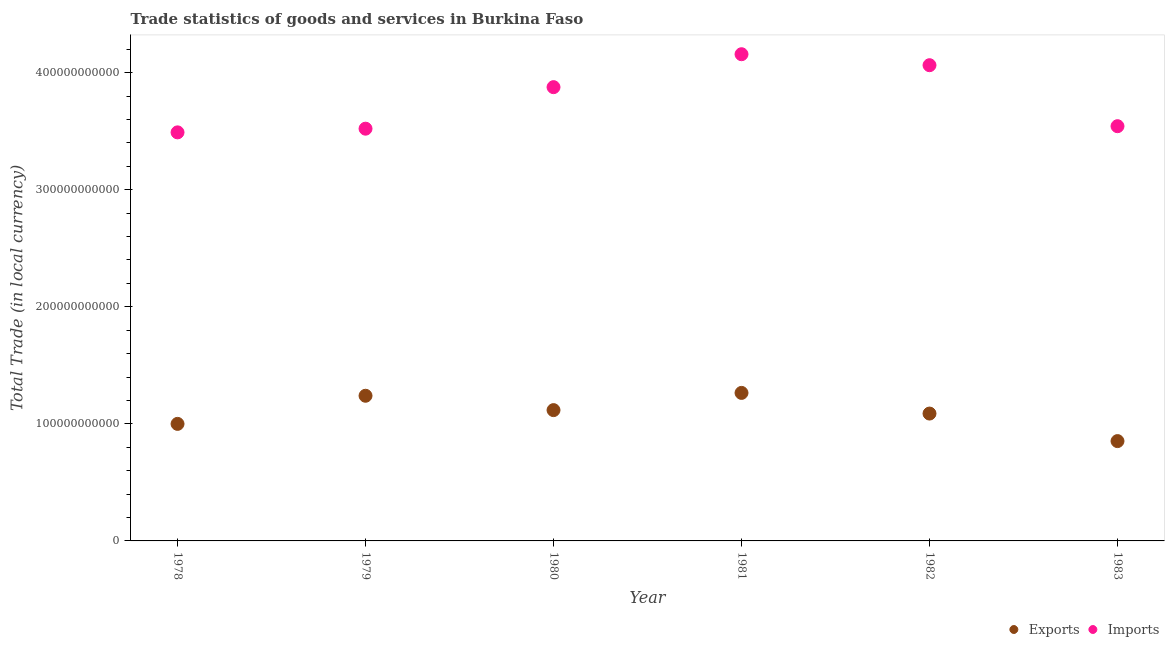How many different coloured dotlines are there?
Keep it short and to the point. 2. What is the imports of goods and services in 1981?
Give a very brief answer. 4.16e+11. Across all years, what is the maximum imports of goods and services?
Offer a very short reply. 4.16e+11. Across all years, what is the minimum export of goods and services?
Give a very brief answer. 8.53e+1. In which year was the export of goods and services minimum?
Offer a terse response. 1983. What is the total export of goods and services in the graph?
Keep it short and to the point. 6.56e+11. What is the difference between the export of goods and services in 1979 and that in 1980?
Offer a terse response. 1.23e+1. What is the difference between the imports of goods and services in 1979 and the export of goods and services in 1978?
Offer a very short reply. 2.52e+11. What is the average imports of goods and services per year?
Keep it short and to the point. 3.78e+11. In the year 1978, what is the difference between the imports of goods and services and export of goods and services?
Ensure brevity in your answer.  2.49e+11. What is the ratio of the imports of goods and services in 1981 to that in 1983?
Your response must be concise. 1.17. Is the difference between the export of goods and services in 1982 and 1983 greater than the difference between the imports of goods and services in 1982 and 1983?
Give a very brief answer. No. What is the difference between the highest and the second highest export of goods and services?
Make the answer very short. 2.44e+09. What is the difference between the highest and the lowest imports of goods and services?
Your answer should be very brief. 6.68e+1. In how many years, is the export of goods and services greater than the average export of goods and services taken over all years?
Your answer should be very brief. 3. Is the sum of the imports of goods and services in 1978 and 1979 greater than the maximum export of goods and services across all years?
Your answer should be very brief. Yes. Is the export of goods and services strictly greater than the imports of goods and services over the years?
Offer a very short reply. No. Is the export of goods and services strictly less than the imports of goods and services over the years?
Give a very brief answer. Yes. What is the difference between two consecutive major ticks on the Y-axis?
Provide a short and direct response. 1.00e+11. Does the graph contain any zero values?
Make the answer very short. No. How many legend labels are there?
Provide a short and direct response. 2. How are the legend labels stacked?
Offer a very short reply. Horizontal. What is the title of the graph?
Offer a very short reply. Trade statistics of goods and services in Burkina Faso. What is the label or title of the X-axis?
Provide a short and direct response. Year. What is the label or title of the Y-axis?
Keep it short and to the point. Total Trade (in local currency). What is the Total Trade (in local currency) of Exports in 1978?
Give a very brief answer. 1.00e+11. What is the Total Trade (in local currency) in Imports in 1978?
Your answer should be very brief. 3.49e+11. What is the Total Trade (in local currency) in Exports in 1979?
Keep it short and to the point. 1.24e+11. What is the Total Trade (in local currency) of Imports in 1979?
Provide a short and direct response. 3.52e+11. What is the Total Trade (in local currency) of Exports in 1980?
Make the answer very short. 1.12e+11. What is the Total Trade (in local currency) in Imports in 1980?
Your answer should be compact. 3.88e+11. What is the Total Trade (in local currency) in Exports in 1981?
Make the answer very short. 1.26e+11. What is the Total Trade (in local currency) of Imports in 1981?
Keep it short and to the point. 4.16e+11. What is the Total Trade (in local currency) in Exports in 1982?
Ensure brevity in your answer.  1.09e+11. What is the Total Trade (in local currency) of Imports in 1982?
Provide a short and direct response. 4.06e+11. What is the Total Trade (in local currency) of Exports in 1983?
Offer a terse response. 8.53e+1. What is the Total Trade (in local currency) in Imports in 1983?
Your response must be concise. 3.54e+11. Across all years, what is the maximum Total Trade (in local currency) of Exports?
Make the answer very short. 1.26e+11. Across all years, what is the maximum Total Trade (in local currency) of Imports?
Make the answer very short. 4.16e+11. Across all years, what is the minimum Total Trade (in local currency) of Exports?
Make the answer very short. 8.53e+1. Across all years, what is the minimum Total Trade (in local currency) of Imports?
Keep it short and to the point. 3.49e+11. What is the total Total Trade (in local currency) of Exports in the graph?
Keep it short and to the point. 6.56e+11. What is the total Total Trade (in local currency) of Imports in the graph?
Offer a very short reply. 2.27e+12. What is the difference between the Total Trade (in local currency) of Exports in 1978 and that in 1979?
Keep it short and to the point. -2.40e+1. What is the difference between the Total Trade (in local currency) of Imports in 1978 and that in 1979?
Provide a succinct answer. -3.14e+09. What is the difference between the Total Trade (in local currency) in Exports in 1978 and that in 1980?
Offer a very short reply. -1.18e+1. What is the difference between the Total Trade (in local currency) of Imports in 1978 and that in 1980?
Your answer should be compact. -3.86e+1. What is the difference between the Total Trade (in local currency) of Exports in 1978 and that in 1981?
Provide a short and direct response. -2.65e+1. What is the difference between the Total Trade (in local currency) in Imports in 1978 and that in 1981?
Your answer should be compact. -6.68e+1. What is the difference between the Total Trade (in local currency) in Exports in 1978 and that in 1982?
Your answer should be very brief. -8.82e+09. What is the difference between the Total Trade (in local currency) in Imports in 1978 and that in 1982?
Keep it short and to the point. -5.74e+1. What is the difference between the Total Trade (in local currency) of Exports in 1978 and that in 1983?
Offer a terse response. 1.47e+1. What is the difference between the Total Trade (in local currency) of Imports in 1978 and that in 1983?
Make the answer very short. -5.27e+09. What is the difference between the Total Trade (in local currency) of Exports in 1979 and that in 1980?
Your response must be concise. 1.23e+1. What is the difference between the Total Trade (in local currency) in Imports in 1979 and that in 1980?
Offer a very short reply. -3.55e+1. What is the difference between the Total Trade (in local currency) of Exports in 1979 and that in 1981?
Ensure brevity in your answer.  -2.44e+09. What is the difference between the Total Trade (in local currency) of Imports in 1979 and that in 1981?
Your answer should be very brief. -6.36e+1. What is the difference between the Total Trade (in local currency) in Exports in 1979 and that in 1982?
Make the answer very short. 1.52e+1. What is the difference between the Total Trade (in local currency) in Imports in 1979 and that in 1982?
Provide a short and direct response. -5.42e+1. What is the difference between the Total Trade (in local currency) in Exports in 1979 and that in 1983?
Offer a very short reply. 3.87e+1. What is the difference between the Total Trade (in local currency) in Imports in 1979 and that in 1983?
Provide a succinct answer. -2.13e+09. What is the difference between the Total Trade (in local currency) in Exports in 1980 and that in 1981?
Make the answer very short. -1.47e+1. What is the difference between the Total Trade (in local currency) of Imports in 1980 and that in 1981?
Keep it short and to the point. -2.81e+1. What is the difference between the Total Trade (in local currency) of Exports in 1980 and that in 1982?
Your answer should be very brief. 2.94e+09. What is the difference between the Total Trade (in local currency) of Imports in 1980 and that in 1982?
Provide a succinct answer. -1.88e+1. What is the difference between the Total Trade (in local currency) of Exports in 1980 and that in 1983?
Make the answer very short. 2.65e+1. What is the difference between the Total Trade (in local currency) in Imports in 1980 and that in 1983?
Your answer should be compact. 3.33e+1. What is the difference between the Total Trade (in local currency) of Exports in 1981 and that in 1982?
Your response must be concise. 1.76e+1. What is the difference between the Total Trade (in local currency) of Imports in 1981 and that in 1982?
Ensure brevity in your answer.  9.38e+09. What is the difference between the Total Trade (in local currency) of Exports in 1981 and that in 1983?
Give a very brief answer. 4.12e+1. What is the difference between the Total Trade (in local currency) of Imports in 1981 and that in 1983?
Give a very brief answer. 6.15e+1. What is the difference between the Total Trade (in local currency) in Exports in 1982 and that in 1983?
Keep it short and to the point. 2.35e+1. What is the difference between the Total Trade (in local currency) in Imports in 1982 and that in 1983?
Provide a succinct answer. 5.21e+1. What is the difference between the Total Trade (in local currency) in Exports in 1978 and the Total Trade (in local currency) in Imports in 1979?
Offer a very short reply. -2.52e+11. What is the difference between the Total Trade (in local currency) in Exports in 1978 and the Total Trade (in local currency) in Imports in 1980?
Your answer should be compact. -2.88e+11. What is the difference between the Total Trade (in local currency) of Exports in 1978 and the Total Trade (in local currency) of Imports in 1981?
Your response must be concise. -3.16e+11. What is the difference between the Total Trade (in local currency) of Exports in 1978 and the Total Trade (in local currency) of Imports in 1982?
Keep it short and to the point. -3.06e+11. What is the difference between the Total Trade (in local currency) in Exports in 1978 and the Total Trade (in local currency) in Imports in 1983?
Your response must be concise. -2.54e+11. What is the difference between the Total Trade (in local currency) of Exports in 1979 and the Total Trade (in local currency) of Imports in 1980?
Offer a terse response. -2.64e+11. What is the difference between the Total Trade (in local currency) in Exports in 1979 and the Total Trade (in local currency) in Imports in 1981?
Provide a succinct answer. -2.92e+11. What is the difference between the Total Trade (in local currency) in Exports in 1979 and the Total Trade (in local currency) in Imports in 1982?
Ensure brevity in your answer.  -2.82e+11. What is the difference between the Total Trade (in local currency) of Exports in 1979 and the Total Trade (in local currency) of Imports in 1983?
Provide a succinct answer. -2.30e+11. What is the difference between the Total Trade (in local currency) in Exports in 1980 and the Total Trade (in local currency) in Imports in 1981?
Your response must be concise. -3.04e+11. What is the difference between the Total Trade (in local currency) in Exports in 1980 and the Total Trade (in local currency) in Imports in 1982?
Offer a terse response. -2.95e+11. What is the difference between the Total Trade (in local currency) in Exports in 1980 and the Total Trade (in local currency) in Imports in 1983?
Offer a terse response. -2.43e+11. What is the difference between the Total Trade (in local currency) in Exports in 1981 and the Total Trade (in local currency) in Imports in 1982?
Provide a succinct answer. -2.80e+11. What is the difference between the Total Trade (in local currency) of Exports in 1981 and the Total Trade (in local currency) of Imports in 1983?
Make the answer very short. -2.28e+11. What is the difference between the Total Trade (in local currency) of Exports in 1982 and the Total Trade (in local currency) of Imports in 1983?
Give a very brief answer. -2.46e+11. What is the average Total Trade (in local currency) of Exports per year?
Make the answer very short. 1.09e+11. What is the average Total Trade (in local currency) in Imports per year?
Your answer should be compact. 3.78e+11. In the year 1978, what is the difference between the Total Trade (in local currency) of Exports and Total Trade (in local currency) of Imports?
Give a very brief answer. -2.49e+11. In the year 1979, what is the difference between the Total Trade (in local currency) in Exports and Total Trade (in local currency) in Imports?
Provide a succinct answer. -2.28e+11. In the year 1980, what is the difference between the Total Trade (in local currency) of Exports and Total Trade (in local currency) of Imports?
Provide a short and direct response. -2.76e+11. In the year 1981, what is the difference between the Total Trade (in local currency) of Exports and Total Trade (in local currency) of Imports?
Offer a very short reply. -2.89e+11. In the year 1982, what is the difference between the Total Trade (in local currency) of Exports and Total Trade (in local currency) of Imports?
Your answer should be compact. -2.98e+11. In the year 1983, what is the difference between the Total Trade (in local currency) in Exports and Total Trade (in local currency) in Imports?
Your answer should be very brief. -2.69e+11. What is the ratio of the Total Trade (in local currency) in Exports in 1978 to that in 1979?
Provide a succinct answer. 0.81. What is the ratio of the Total Trade (in local currency) in Imports in 1978 to that in 1979?
Keep it short and to the point. 0.99. What is the ratio of the Total Trade (in local currency) in Exports in 1978 to that in 1980?
Your answer should be compact. 0.89. What is the ratio of the Total Trade (in local currency) of Imports in 1978 to that in 1980?
Make the answer very short. 0.9. What is the ratio of the Total Trade (in local currency) of Exports in 1978 to that in 1981?
Make the answer very short. 0.79. What is the ratio of the Total Trade (in local currency) in Imports in 1978 to that in 1981?
Offer a very short reply. 0.84. What is the ratio of the Total Trade (in local currency) of Exports in 1978 to that in 1982?
Your answer should be very brief. 0.92. What is the ratio of the Total Trade (in local currency) of Imports in 1978 to that in 1982?
Give a very brief answer. 0.86. What is the ratio of the Total Trade (in local currency) of Exports in 1978 to that in 1983?
Make the answer very short. 1.17. What is the ratio of the Total Trade (in local currency) in Imports in 1978 to that in 1983?
Keep it short and to the point. 0.99. What is the ratio of the Total Trade (in local currency) in Exports in 1979 to that in 1980?
Provide a succinct answer. 1.11. What is the ratio of the Total Trade (in local currency) in Imports in 1979 to that in 1980?
Keep it short and to the point. 0.91. What is the ratio of the Total Trade (in local currency) in Exports in 1979 to that in 1981?
Your answer should be very brief. 0.98. What is the ratio of the Total Trade (in local currency) of Imports in 1979 to that in 1981?
Offer a very short reply. 0.85. What is the ratio of the Total Trade (in local currency) in Exports in 1979 to that in 1982?
Provide a short and direct response. 1.14. What is the ratio of the Total Trade (in local currency) of Imports in 1979 to that in 1982?
Offer a terse response. 0.87. What is the ratio of the Total Trade (in local currency) in Exports in 1979 to that in 1983?
Your answer should be compact. 1.45. What is the ratio of the Total Trade (in local currency) of Imports in 1979 to that in 1983?
Make the answer very short. 0.99. What is the ratio of the Total Trade (in local currency) of Exports in 1980 to that in 1981?
Offer a terse response. 0.88. What is the ratio of the Total Trade (in local currency) in Imports in 1980 to that in 1981?
Provide a short and direct response. 0.93. What is the ratio of the Total Trade (in local currency) in Exports in 1980 to that in 1982?
Ensure brevity in your answer.  1.03. What is the ratio of the Total Trade (in local currency) of Imports in 1980 to that in 1982?
Ensure brevity in your answer.  0.95. What is the ratio of the Total Trade (in local currency) in Exports in 1980 to that in 1983?
Keep it short and to the point. 1.31. What is the ratio of the Total Trade (in local currency) in Imports in 1980 to that in 1983?
Make the answer very short. 1.09. What is the ratio of the Total Trade (in local currency) in Exports in 1981 to that in 1982?
Make the answer very short. 1.16. What is the ratio of the Total Trade (in local currency) in Imports in 1981 to that in 1982?
Provide a succinct answer. 1.02. What is the ratio of the Total Trade (in local currency) of Exports in 1981 to that in 1983?
Your response must be concise. 1.48. What is the ratio of the Total Trade (in local currency) of Imports in 1981 to that in 1983?
Offer a terse response. 1.17. What is the ratio of the Total Trade (in local currency) in Exports in 1982 to that in 1983?
Your answer should be compact. 1.28. What is the ratio of the Total Trade (in local currency) of Imports in 1982 to that in 1983?
Give a very brief answer. 1.15. What is the difference between the highest and the second highest Total Trade (in local currency) in Exports?
Provide a short and direct response. 2.44e+09. What is the difference between the highest and the second highest Total Trade (in local currency) of Imports?
Your answer should be very brief. 9.38e+09. What is the difference between the highest and the lowest Total Trade (in local currency) in Exports?
Give a very brief answer. 4.12e+1. What is the difference between the highest and the lowest Total Trade (in local currency) of Imports?
Provide a short and direct response. 6.68e+1. 